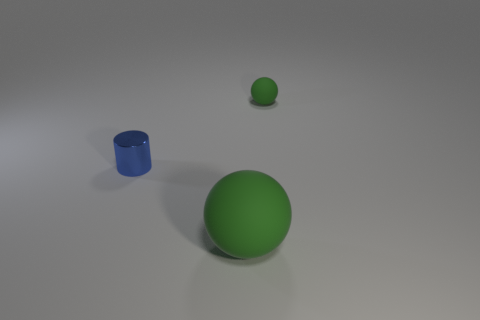Add 3 tiny green rubber objects. How many objects exist? 6 Subtract all balls. How many objects are left? 1 Add 2 blue metal objects. How many blue metal objects are left? 3 Add 2 big green things. How many big green things exist? 3 Subtract 0 gray cubes. How many objects are left? 3 Subtract all tiny blue metal objects. Subtract all big rubber objects. How many objects are left? 1 